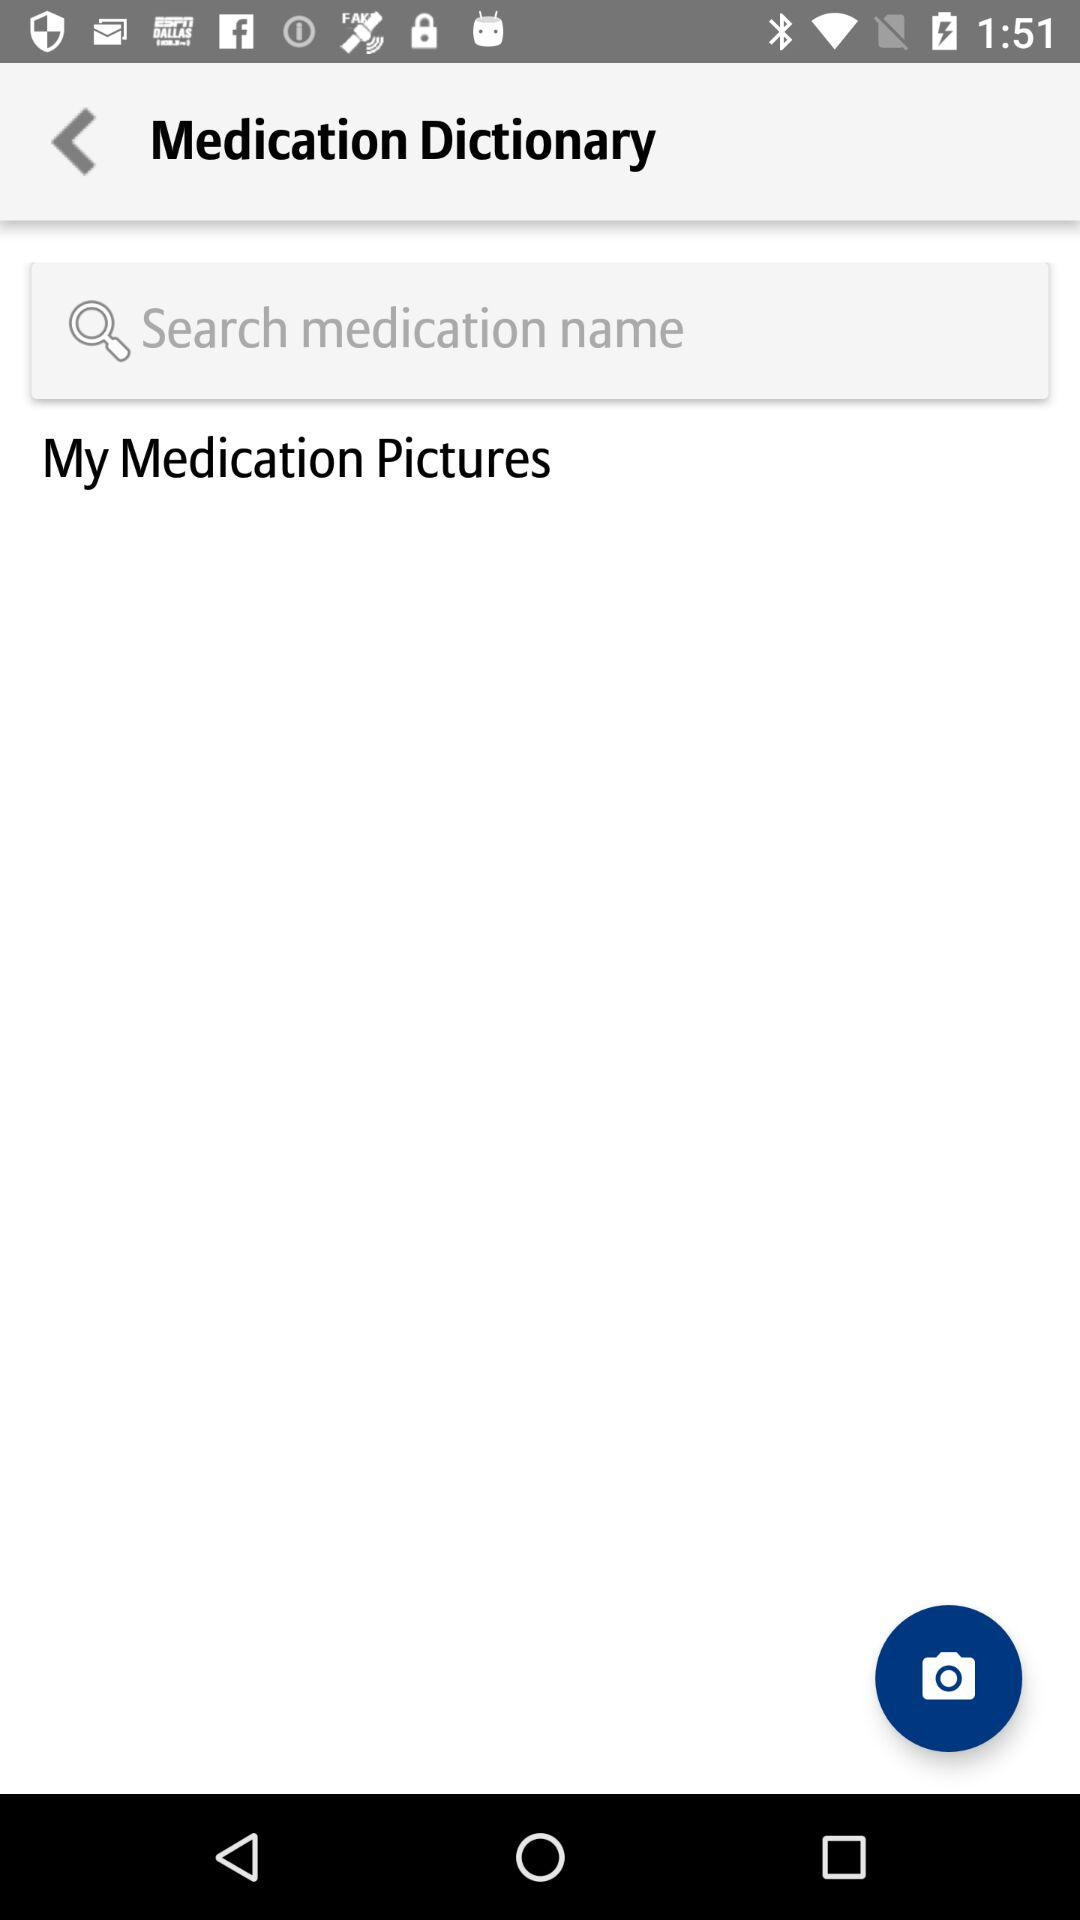What is the name of application?
When the provided information is insufficient, respond with <no answer>. <no answer> 